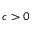<formula> <loc_0><loc_0><loc_500><loc_500>c > 0</formula> 